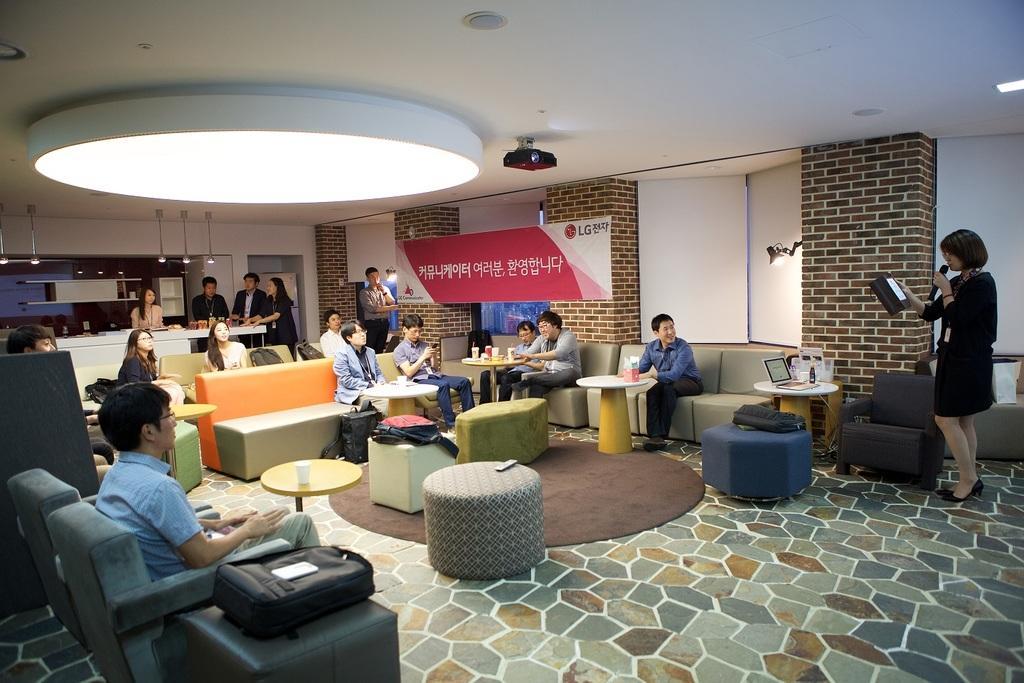Describe this image in one or two sentences. In the middle of the image there are few chairs and tables on the tables there are some laptops, cups, bags and bottles and few people are sitting on chairs. Top right side of the image a woman is standing and holding a microphone and speaking. Top left side of the image few people are standing and watching. Top of the image there is a roof and light and there is a projector. In the middle of the image there is a wall on the wall there is a banner. 